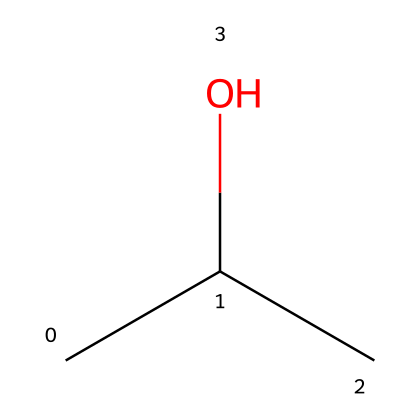How many carbon atoms are in isopropyl alcohol? The SMILES representation "CC(C)O" shows three carbon atoms. Each "C" represents a carbon atom, and there are three occurrences of "C" in the sequence.
Answer: three What functional group is present in isopropyl alcohol? The presence of "-OH" in the SMILES indicates a hydroxyl group, which is the characteristic functional group of alcohols.
Answer: hydroxyl group How many hydrogen atoms are in isopropyl alcohol? The structure corresponds to three carbon atoms bound to a hydroxyl group. Each carbon can be bonded to additional hydrogen atoms; in this case, the structure has a total of eight hydrogen atoms.
Answer: eight Is isopropyl alcohol a primary, secondary, or tertiary alcohol? In the structure CC(C)O, the central carbon atom is connected to two other carbon atoms and one hydroxyl group, which classifies isopropyl alcohol as a secondary alcohol.
Answer: secondary What type of chemical compound is isopropyl alcohol classified as? Isopropyl alcohol is classified as a flammable liquid due to its molecular structure. Its ability to vaporize quickly at room temperature is a key characteristic of flammable liquids.
Answer: flammable liquid What is the molecular formula for isopropyl alcohol? Based on the SMILES representation, the molecular formula can be derived as C3H8O, accounting for three carbons, eight hydrogens, and one oxygen.
Answer: C3H8O 